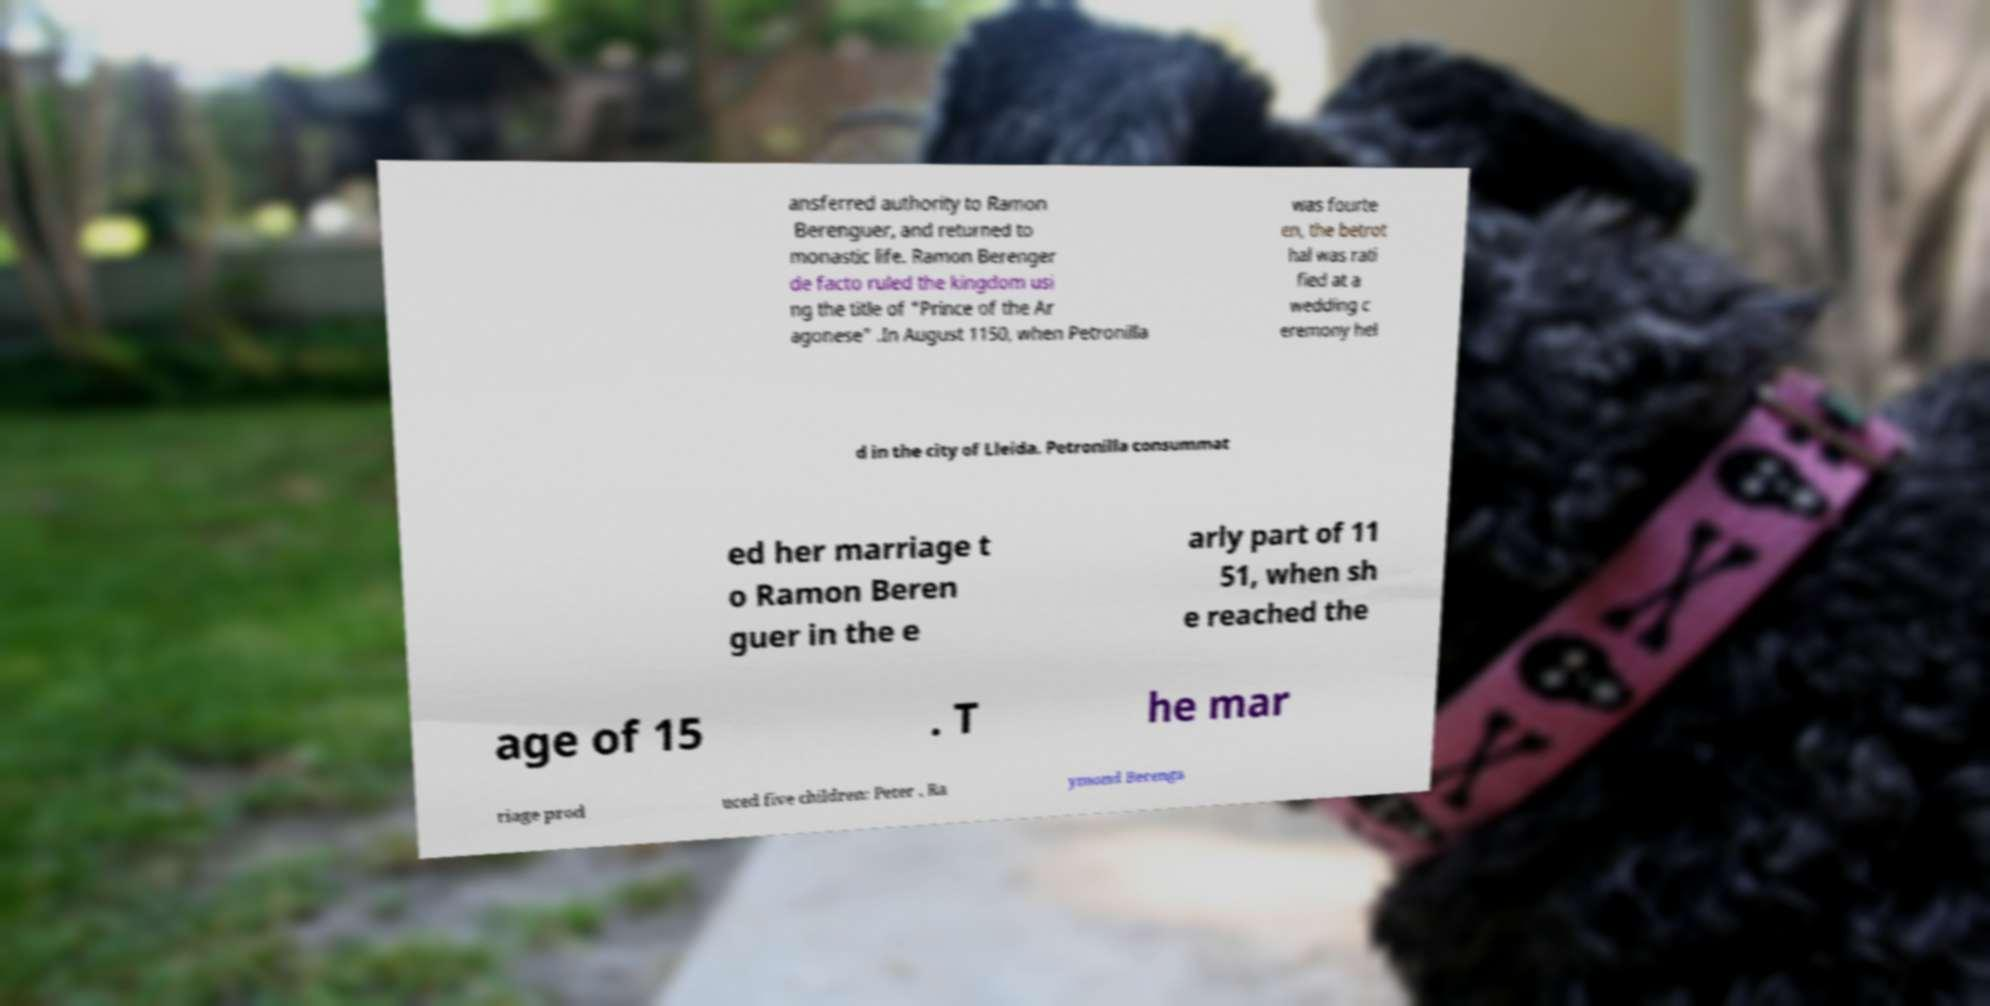Can you read and provide the text displayed in the image?This photo seems to have some interesting text. Can you extract and type it out for me? ansferred authority to Ramon Berenguer, and returned to monastic life. Ramon Berenger de facto ruled the kingdom usi ng the title of "Prince of the Ar agonese" .In August 1150, when Petronilla was fourte en, the betrot hal was rati fied at a wedding c eremony hel d in the city of Lleida. Petronilla consummat ed her marriage t o Ramon Beren guer in the e arly part of 11 51, when sh e reached the age of 15 . T he mar riage prod uced five children: Peter , Ra ymond Berenga 